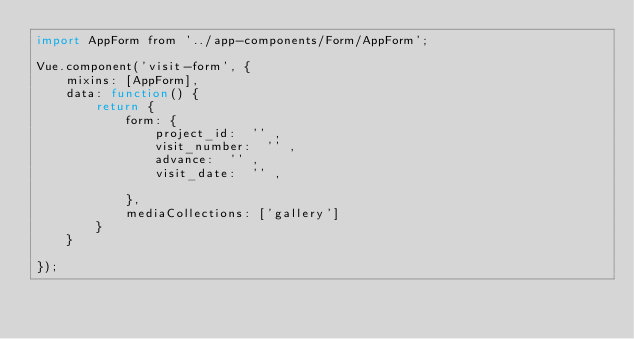Convert code to text. <code><loc_0><loc_0><loc_500><loc_500><_JavaScript_>import AppForm from '../app-components/Form/AppForm';

Vue.component('visit-form', {
    mixins: [AppForm],
    data: function() {
        return {
            form: {
                project_id:  '' ,
                visit_number:  '' ,
                advance:  '' ,
                visit_date:  '' ,

            },
            mediaCollections: ['gallery']
        }
    }

});
</code> 